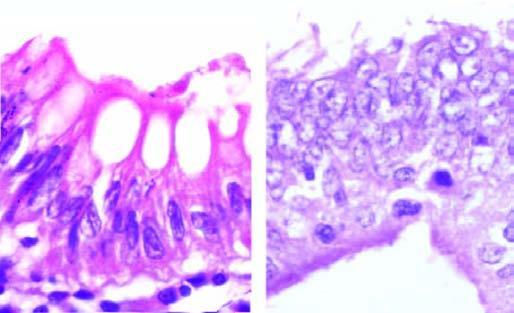what is contrasted with normal basal polarity in columnar epithelium?
Answer the question using a single word or phrase. Microscopic appearance of loss of nuclear polarity 